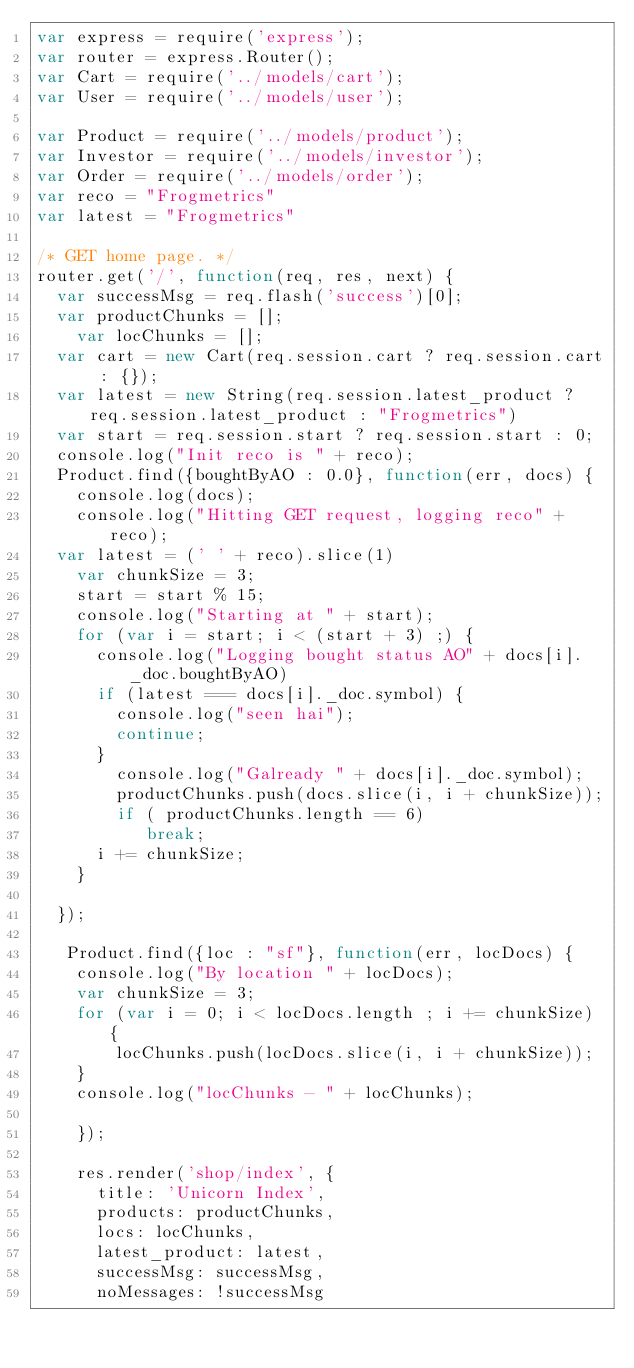<code> <loc_0><loc_0><loc_500><loc_500><_JavaScript_>var express = require('express');
var router = express.Router();
var Cart = require('../models/cart');
var User = require('../models/user');

var Product = require('../models/product');
var Investor = require('../models/investor');
var Order = require('../models/order');
var reco = "Frogmetrics"
var latest = "Frogmetrics"

/* GET home page. */
router.get('/', function(req, res, next) {
  var successMsg = req.flash('success')[0];
  var productChunks = [];
    var locChunks = [];
  var cart = new Cart(req.session.cart ? req.session.cart : {});
  var latest = new String(req.session.latest_product ? req.session.latest_product : "Frogmetrics")
  var start = req.session.start ? req.session.start : 0;
  console.log("Init reco is " + reco);
  Product.find({boughtByAO : 0.0}, function(err, docs) {
    console.log(docs);
    console.log("Hitting GET request, logging reco" + reco);
  var latest = (' ' + reco).slice(1)
    var chunkSize = 3;
    start = start % 15;
    console.log("Starting at " + start);
    for (var i = start; i < (start + 3) ;) {
      console.log("Logging bought status AO" + docs[i]._doc.boughtByAO)
      if (latest === docs[i]._doc.symbol) {
        console.log("seen hai");
        continue;
      }
        console.log("Galready " + docs[i]._doc.symbol);
        productChunks.push(docs.slice(i, i + chunkSize));
        if ( productChunks.length == 6)
           break;
      i += chunkSize;
    }
    
  });

   Product.find({loc : "sf"}, function(err, locDocs) {
    console.log("By location " + locDocs);
    var chunkSize = 3;
    for (var i = 0; i < locDocs.length ; i += chunkSize) {
        locChunks.push(locDocs.slice(i, i + chunkSize));
    } 
    console.log("locChunks - " + locChunks);

    });

    res.render('shop/index', {
      title: 'Unicorn Index',
      products: productChunks,
      locs: locChunks,
      latest_product: latest,
      successMsg: successMsg,
      noMessages: !successMsg</code> 